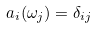<formula> <loc_0><loc_0><loc_500><loc_500>a _ { i } ( \omega _ { j } ) = \delta _ { i j }</formula> 